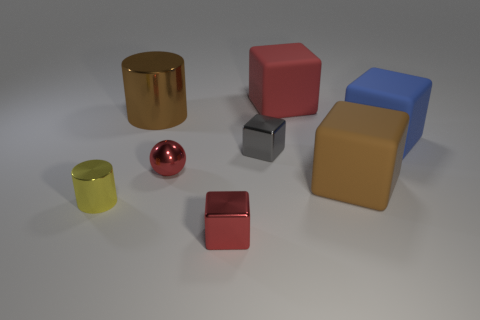Do the large brown object in front of the large brown cylinder and the big blue matte thing have the same shape?
Provide a short and direct response. Yes. How big is the cylinder to the right of the cylinder in front of the tiny sphere?
Keep it short and to the point. Large. What is the color of the tiny sphere that is made of the same material as the small cylinder?
Give a very brief answer. Red. What number of gray metal things are the same size as the gray block?
Your response must be concise. 0. How many gray objects are either small cubes or tiny shiny objects?
Provide a succinct answer. 1. What number of objects are big green blocks or shiny cubes to the left of the gray cube?
Ensure brevity in your answer.  1. There is a large brown thing right of the big brown shiny cylinder; what is its material?
Your answer should be very brief. Rubber. The yellow object that is the same size as the gray metal thing is what shape?
Provide a short and direct response. Cylinder. Are there any brown rubber objects that have the same shape as the red rubber thing?
Your answer should be very brief. Yes. Is the material of the small sphere the same as the big cube to the left of the brown matte cube?
Offer a terse response. No. 